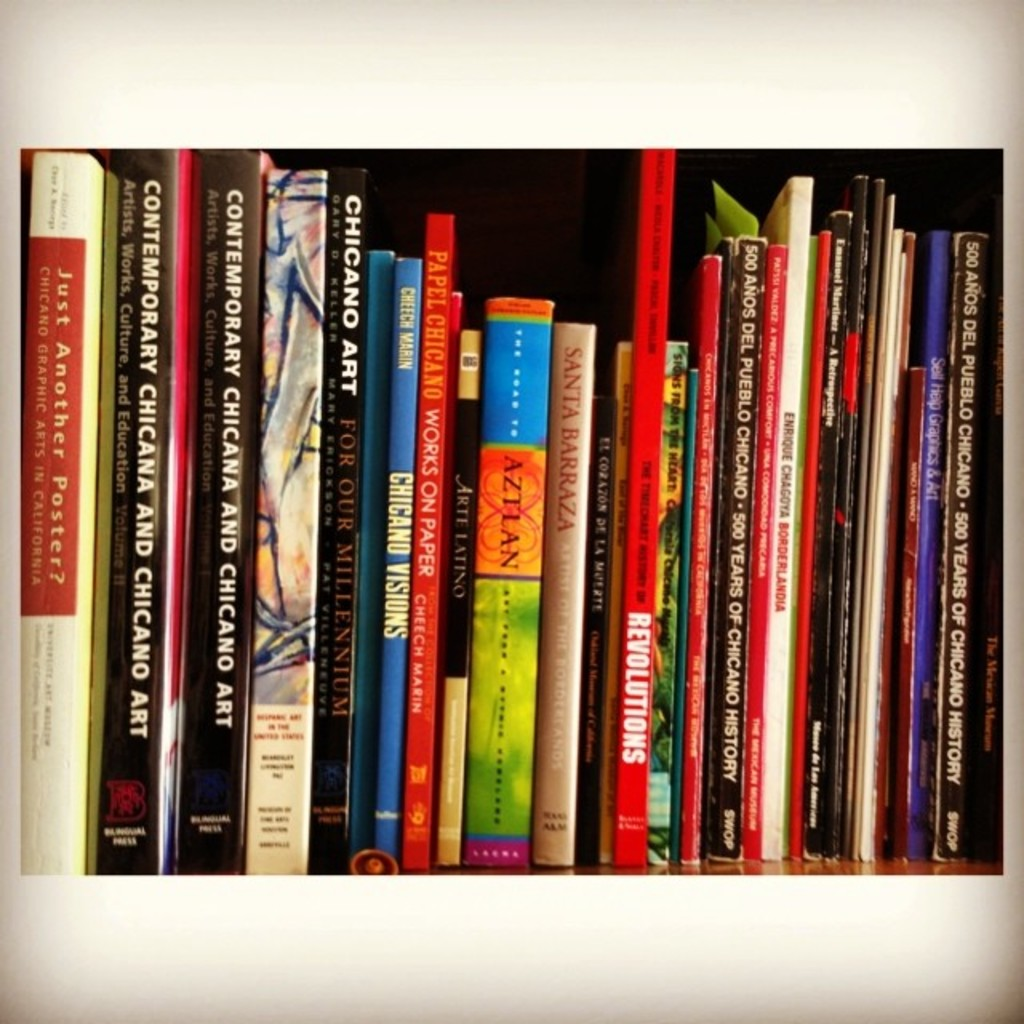Provide a one-sentence caption for the provided image. A diverse collection of books on a shelf, vibrantly showcasing titles focused on Chicago's art and culture scene, each spine telling a different story of creativity and historical perspectives. 